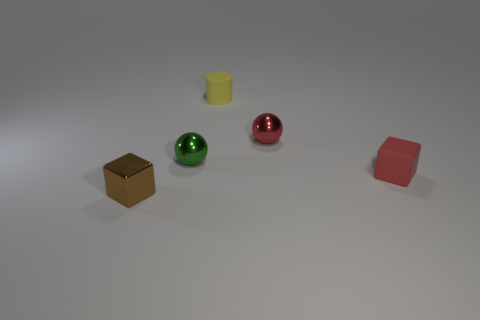What shape is the metallic thing that is the same color as the small matte block?
Give a very brief answer. Sphere. What number of brown objects have the same size as the yellow cylinder?
Give a very brief answer. 1. What shape is the tiny metal object that is on the right side of the yellow matte object?
Ensure brevity in your answer.  Sphere. Is the number of small brown metal things less than the number of large purple rubber blocks?
Keep it short and to the point. No. Are there any other things that are the same color as the small rubber block?
Your response must be concise. Yes. What is the size of the block that is on the left side of the small yellow matte cylinder?
Ensure brevity in your answer.  Small. Is the number of small green cylinders greater than the number of brown shiny blocks?
Give a very brief answer. No. What is the red sphere made of?
Your answer should be very brief. Metal. How many other objects are the same material as the brown block?
Provide a succinct answer. 2. How many green metal cylinders are there?
Your answer should be compact. 0. 